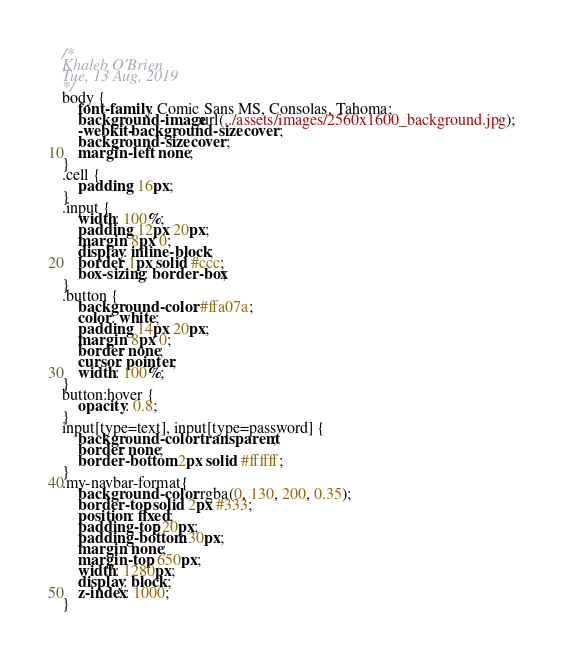Convert code to text. <code><loc_0><loc_0><loc_500><loc_500><_CSS_>/*
Khaleb O'Brien
Tue, 13 Aug, 2019
*/
body {
	font-family: Comic Sans MS, Consolas, Tahoma;
	background-image:url(../assets/images/2560x1600_background.jpg);
	-webkit-background-size: cover;
	background-size: cover;
	margin-left: none;
}
.cell { 
	padding: 16px; 
} 
.input { 
	width: 100%; 
	padding: 12px 20px; 
	margin: 8px 0; 
	display: inline-block; 
	border: 1px solid #ccc; 
	box-sizing: border-box; 
}
.button { 
	background-color: #ffa07a; 
	color: white; 
	padding: 14px 20px; 
	margin: 8px 0; 
	border: none; 
	cursor: pointer; 
	width: 100%; 
} 
button:hover { 
	opacity: 0.8; 
} 
input[type=text], input[type=password] {
	background-color: transparent;
	border: none;
	border-bottom: 2px solid #ffffff;
}
.my-navbar-format{
    background-color: rgba(0, 130, 200, 0.35);
    border-top: solid 2px #333;
    position: fixed;
    padding-top: 20px;
    padding-bottom: 30px;
    margin: none;
    margin-top: 650px;
    width: 1280px;
    display: block;
    z-index: 1000;
}</code> 